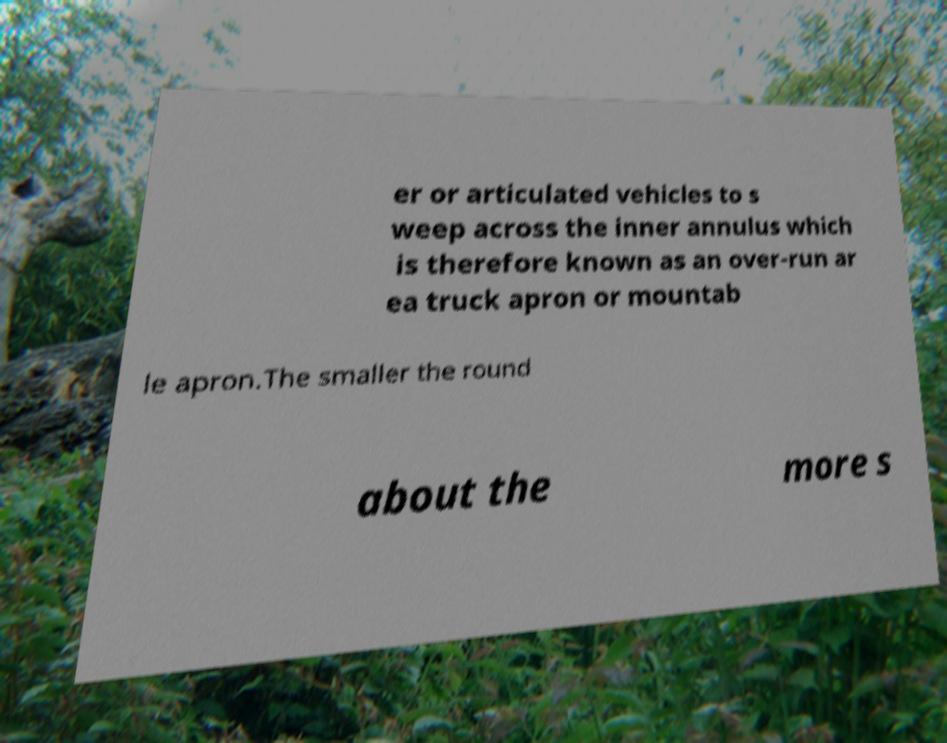Could you assist in decoding the text presented in this image and type it out clearly? er or articulated vehicles to s weep across the inner annulus which is therefore known as an over-run ar ea truck apron or mountab le apron.The smaller the round about the more s 